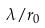<formula> <loc_0><loc_0><loc_500><loc_500>\lambda / r _ { 0 }</formula> 